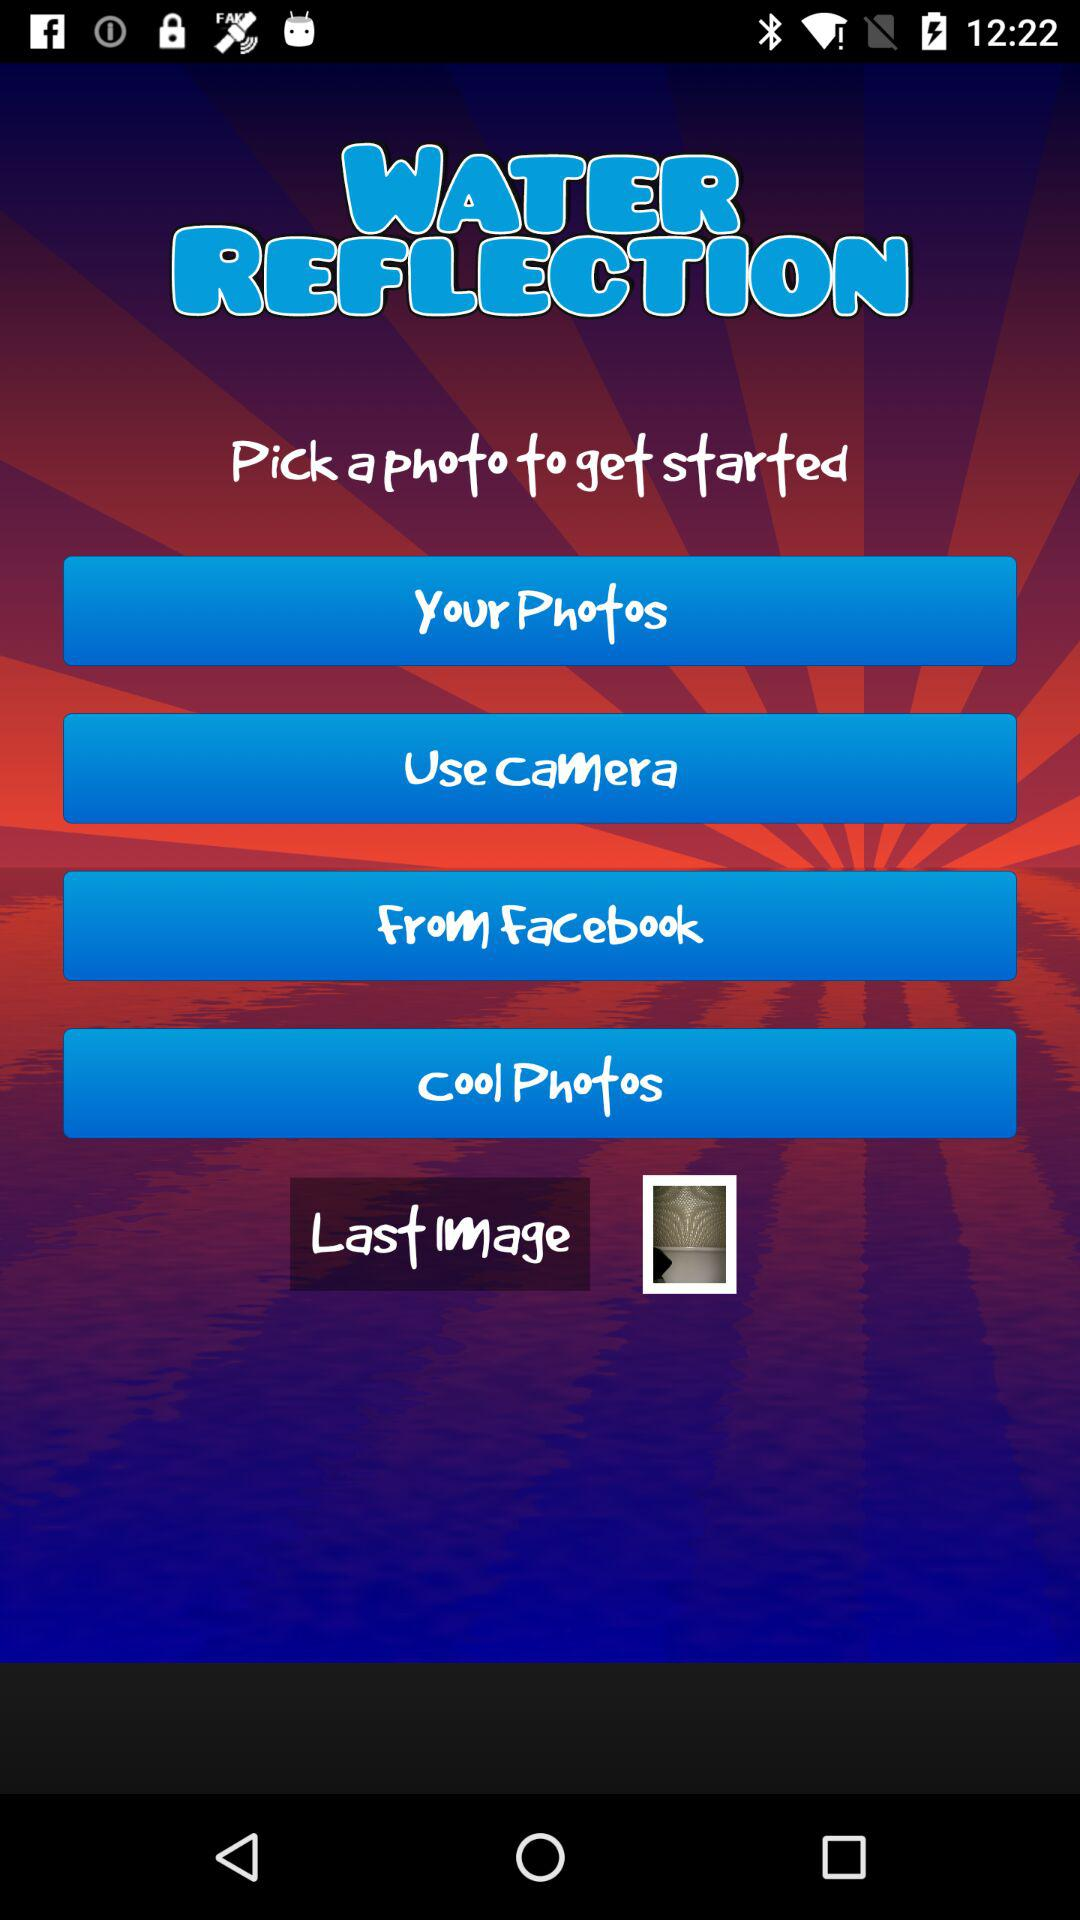What are the options that I can use to pick my photo? The options are "Your Photos", "Use Camera", "From Facebook" and "Cool Photos". 